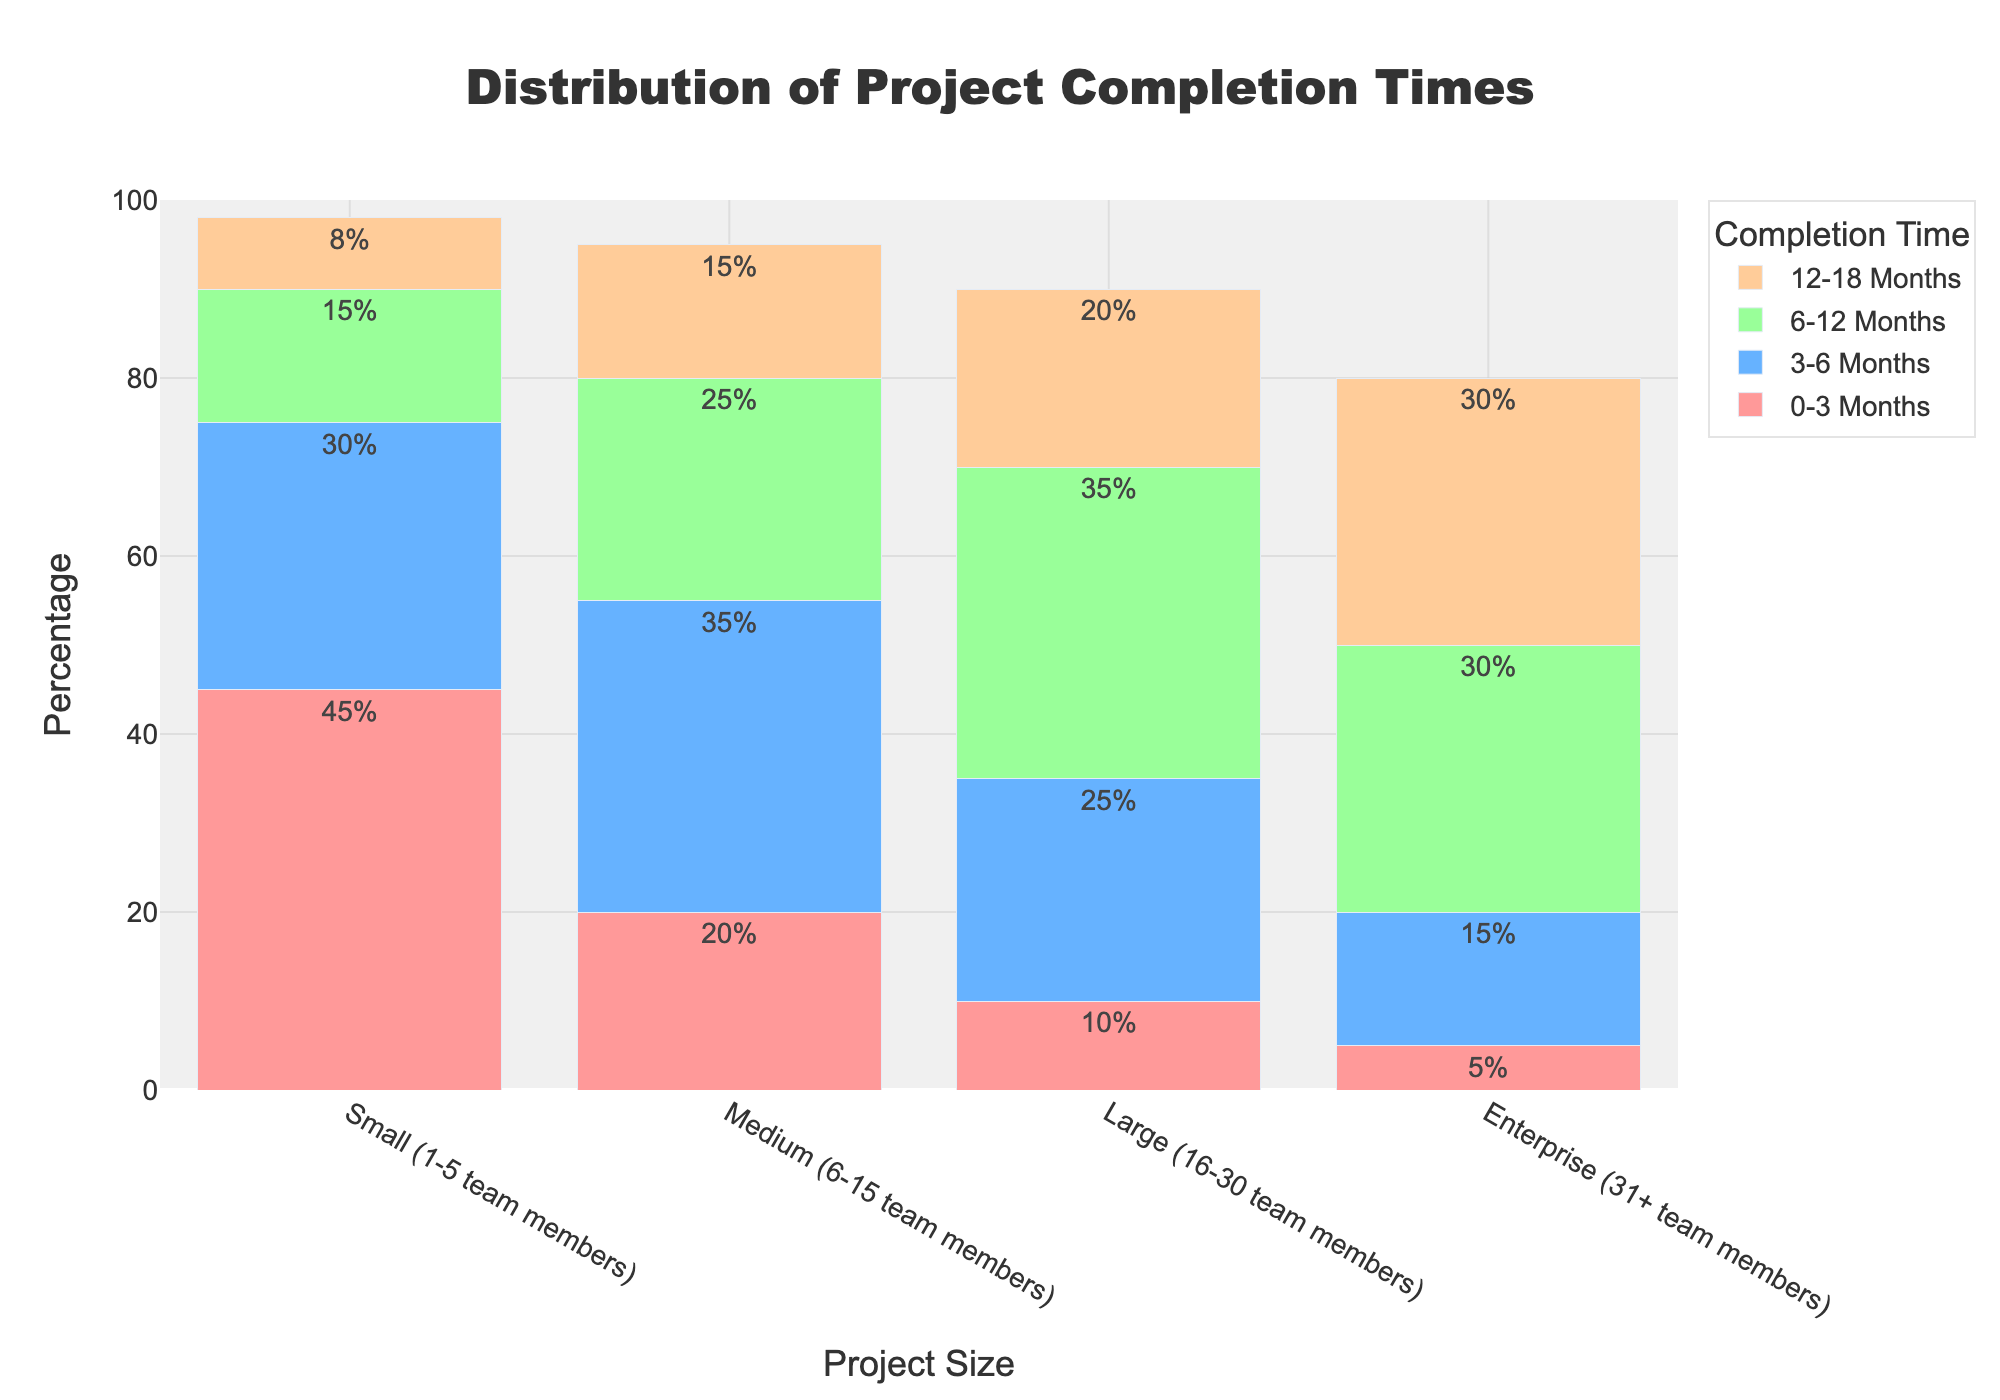What is the percentage of small projects that are completed within 0-6 months? First, add the percentages of small projects completed within 0-3 months and 3-6 months. That is 45% + 30% = 75%.
Answer: 75% Which project size has the highest percentage of projects completed within 6-12 months? Compare the percentages in the 6-12 months category for each project size: Small (15%), Medium (25%), Large (35%), and Enterprise (30%). The highest is for Large projects at 35%.
Answer: Large (35%) How many project sizes have more than 20% of their projects taking 18+ months to complete? Check the percentages for the 18+ months category for each project size: Small (2%), Medium (5%), Large (10%), and Enterprise (20%). Only Enterprise has more than 20%.
Answer: 1 Which project size has the least percentage of projects completed within 0-3 months? Compare the percentages in the 0-3 months category for each project size: Small (45%), Medium (20%), Large (10%), and Enterprise (5%). The smallest percentage is for Enterprise projects at 5%.
Answer: Enterprise (5%) Is the percentage of Medium projects completed within 3-6 months higher or lower than the percentage of Enterprise projects completed within 6-12 months? Look at the completion percentages: Medium within 3-6 months is 35% and Enterprise within 6-12 months is 30%. 35% is higher than 30%.
Answer: Higher Summarize the distribution of project completion times for Large projects. For Large projects, add up the individual percentages to get a complete distribution: 0-3 months (10%), 3-6 months (25%), 6-12 months (35%), 12-18 months (20%), and 18+ months (10%). Thus, the summary is: 
- 10% are completed within 0-3 months
- 25% within 3-6 months
- 35% within 6-12 months
- 20% within 12-18 months
- 10% take more than 18 months
Answer: 10% (0-3 months), 25% (3-6 months), 35% (6-12 months), 20% (12-18 months), 10% (18+ months) Which color represents the 18+ months completion time in the bar chart? Each completion time category is represented by a unique color. The 18+ months category is represented by the color closest to pink shading.
Answer: Pink Are there more projects completed within 0-3 months or 12-18 months across all project sizes? Add the percentages for each project size within the 0-3 months and 12-18 months categories:
- 0-3 months: 45% (Small) + 20% (Medium) + 10% (Large) + 5% (Enterprise) = 80%
- 12-18 months: 8% (Small) + 15% (Medium) + 20% (Large) + 30% (Enterprise) = 73%
80% of projects are completed within 0-3 months, which is more than 73% of projects completed within 12-18 months.
Answer: 0-3 months What is the combined percentage of Small and Medium projects that take more than 18 months to complete? Add the percentages of Small (18+ months: 2%) and Medium (18+ months: 5%) projects. 2% + 5% = 7%.
Answer: 7% 